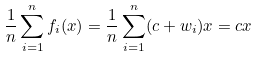Convert formula to latex. <formula><loc_0><loc_0><loc_500><loc_500>\frac { 1 } { n } \sum _ { i = 1 } ^ { n } f _ { i } ( x ) = \frac { 1 } { n } \sum _ { i = 1 } ^ { n } ( c + w _ { i } ) x = c x</formula> 